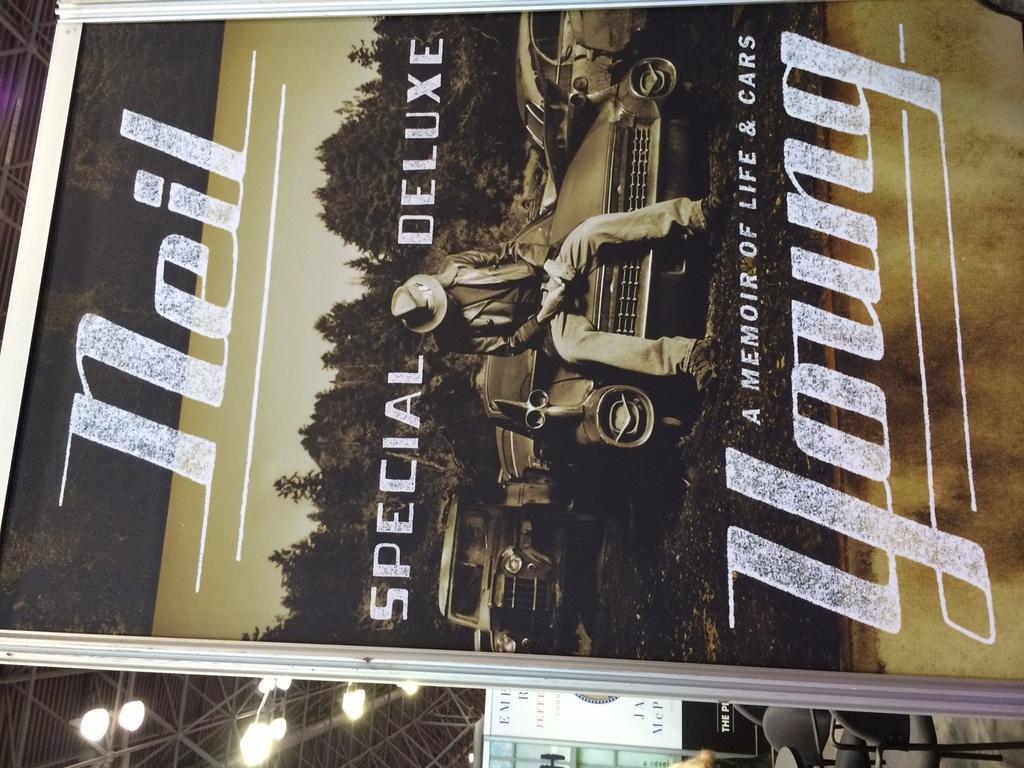How would you summarize this image in a sentence or two? In this image, we can see a poster, on that poster YOUNG is printed. 